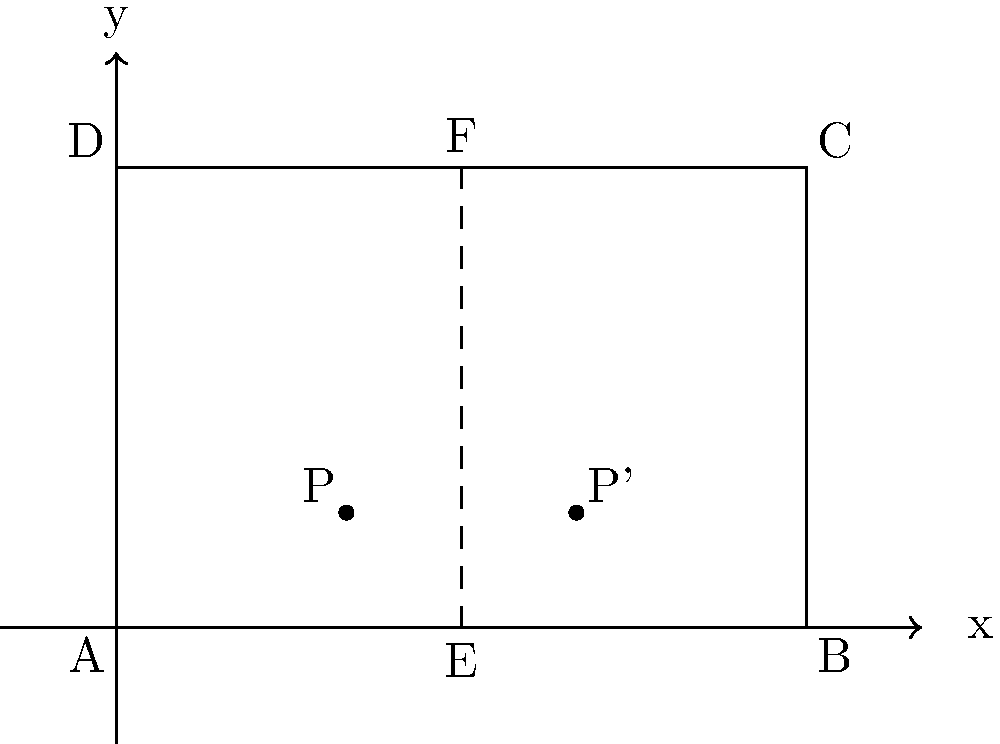In your boutique's storefront window display, you want to create a symmetrical arrangement. The window is represented by the rectangle ABCD, where AB = 6 units and BC = 4 units. Point P(2,1) represents an item in the left half of the display. To achieve perfect symmetry, where should you place the corresponding item P' on the right side of the central axis EF? To find the position of P' that creates a symmetrical arrangement with P:

1) Identify the line of symmetry: The vertical line EF at x = 3 is the axis of symmetry.

2) Reflect point P across the line EF:
   - The x-coordinate of P is 2.
   - The distance from P to the line of symmetry is 3 - 2 = 1 unit.
   - P' should be 1 unit to the right of the line of symmetry.
   - So, the x-coordinate of P' is 3 + 1 = 4.

3) The y-coordinate remains unchanged in a reflection across a vertical line:
   - The y-coordinate of P is 1, so the y-coordinate of P' is also 1.

4) Therefore, the coordinates of P' are (4, 1).

This placement ensures that P and P' are equidistant from the central axis EF, creating a symmetrical display.
Answer: P'(4, 1) 